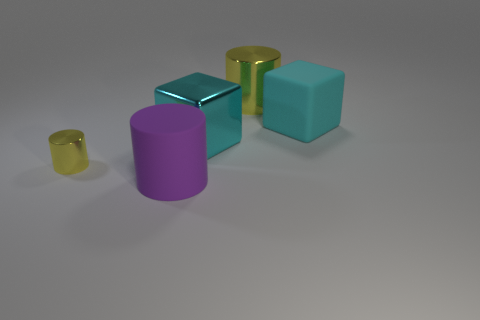Can you describe the scene in terms of object positions and sizes? Certainly! In the image, we have a collection of geometric shapes. There is a large metallic cube with a cyan tone at the back. To its left, we see a smaller, cyan rubber cube. In the foreground, there is a yellow metallic cylinder on the left, considerably smaller than the cyan cube, and a larger purple rubber cylinder on the right. The arrangement and varying sizes create an interesting play of form and depth. 